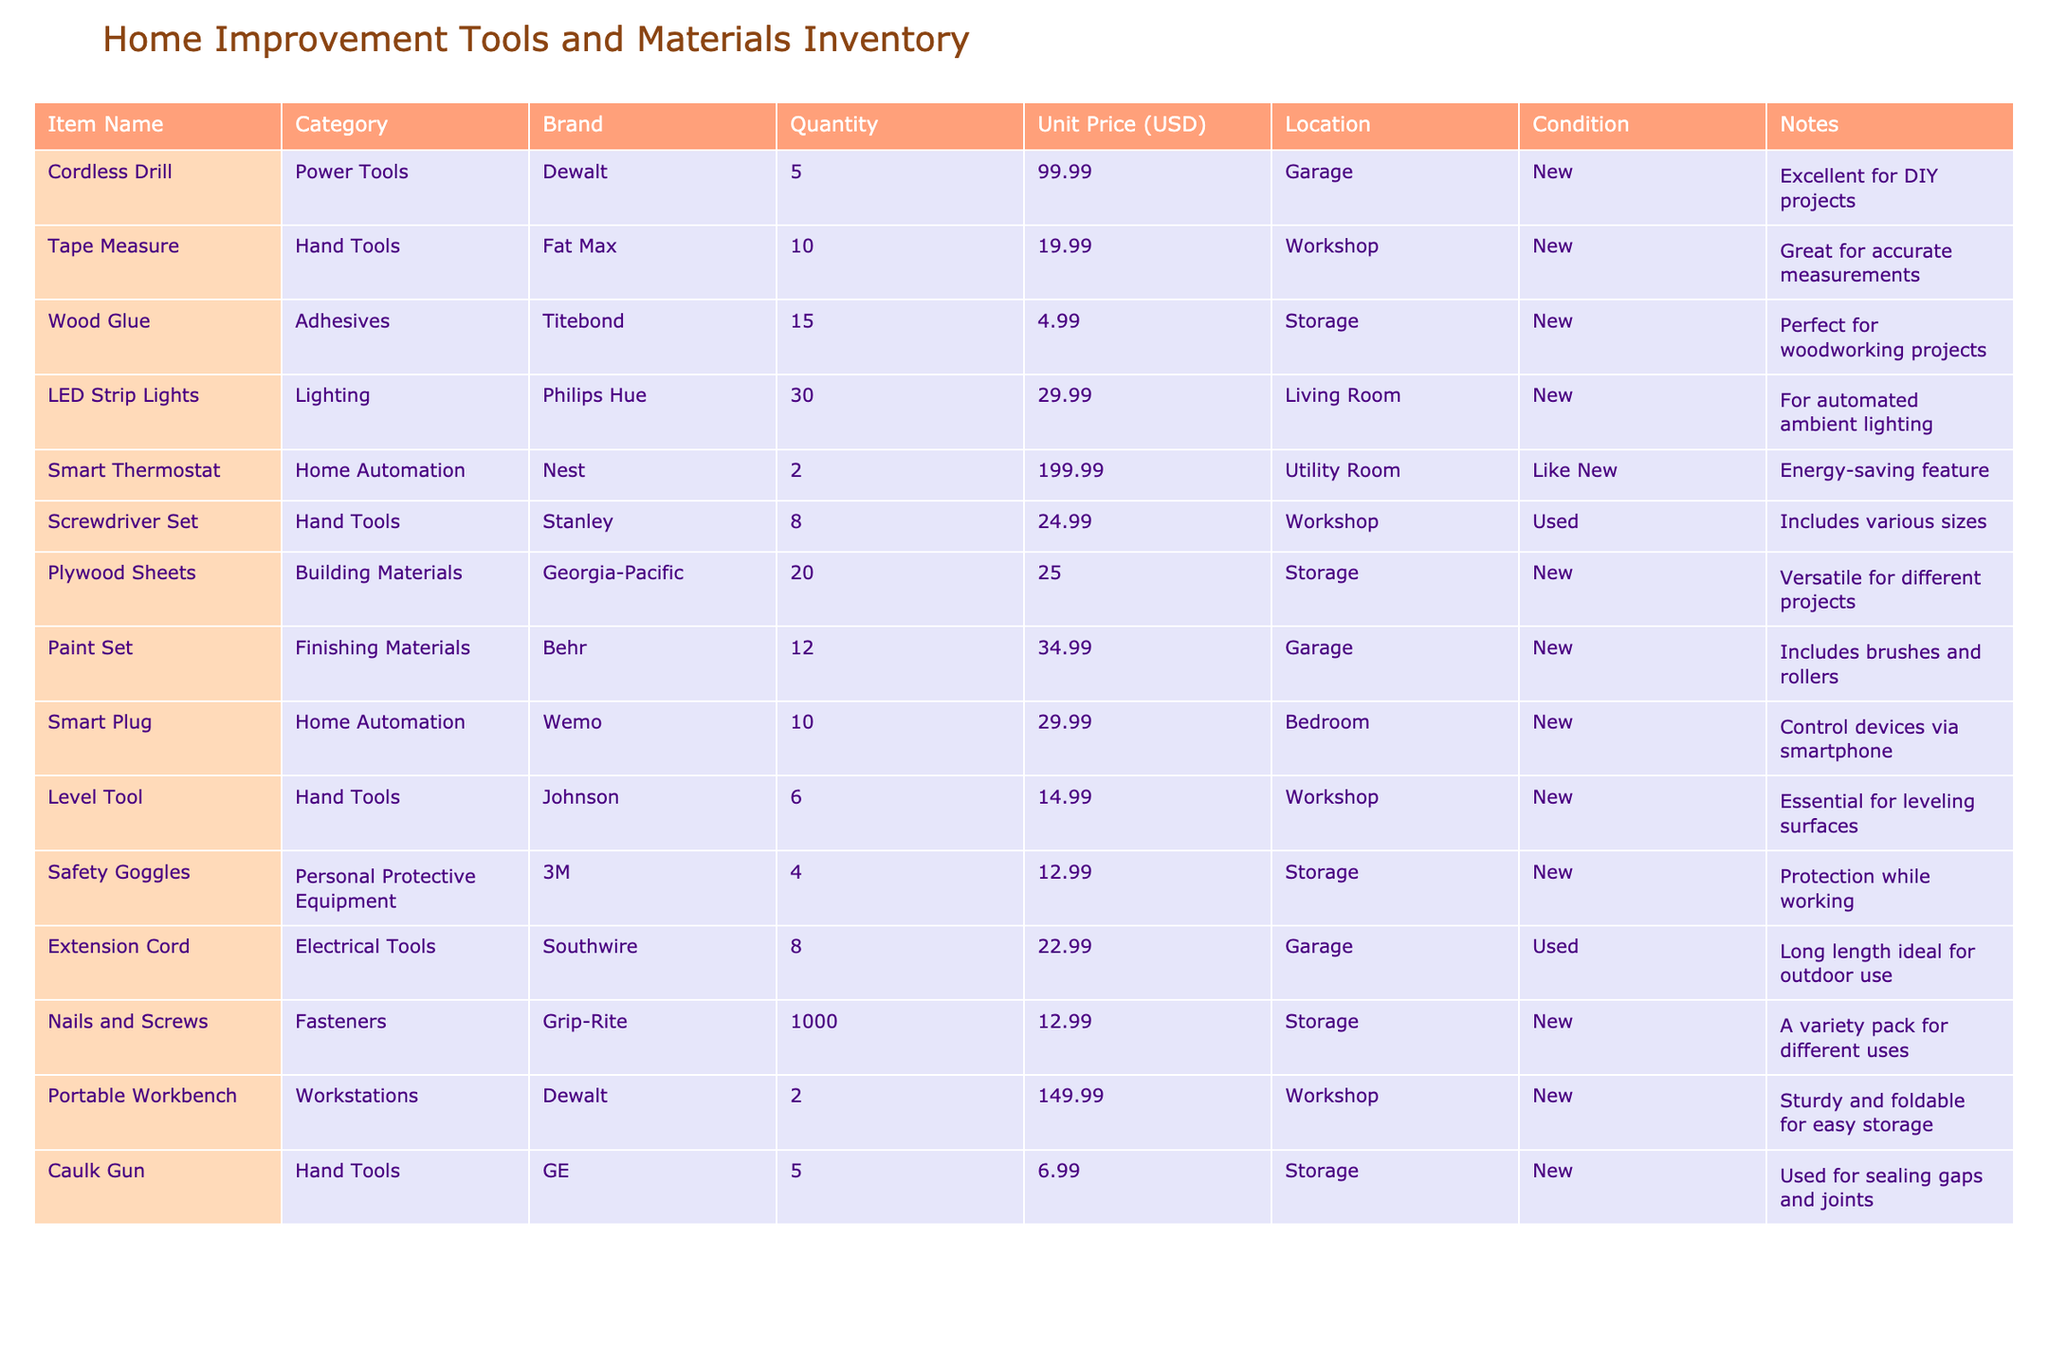What is the quantity of the Smart Thermostat? According to the table, the Smart Thermostat has a quantity listed as 2.
Answer: 2 What is the total quantity of Hand Tools in the inventory? The Hand Tools include Tape Measure (10), Screwdriver Set (8), and Level Tool (6). Adding these together gives 10 + 8 + 6 = 24.
Answer: 24 Are there any items in Used condition? Yes, the Screwdriver Set and Extension Cord are listed as Used.
Answer: Yes How much does the Portable Workbench cost? The table shows that the Portable Workbench has a Unit Price of 149.99 USD.
Answer: 149.99 USD Which items are located in the Workshop? The items located in the Workshop are the Tape Measure, Screwdriver Set, Level Tool, and Portable Workbench.
Answer: Tape Measure, Screwdriver Set, Level Tool, Portable Workbench What is the average price of the Adhesives and Fasteners categories? The Unit Price for Wood Glue in Adhesives is 4.99 USD and for Nails and Screws in Fasteners is 12.99 USD. Calculating the average gives (4.99 + 12.99)/2 = 8.99 USD.
Answer: 8.99 USD Is there a Smart Plug available in the inventory? Yes, there is a Smart Plug listed under Home Automation with a quantity of 10.
Answer: Yes What is the total value of Plywood Sheets in the inventory? The Unit Price for Plywood Sheets is 25.00 USD with a quantity of 20. The total value is calculated by multiplying these two values: 20 * 25.00 = 500.00 USD.
Answer: 500.00 USD How many items in the inventory are priced above 50 USD? The items are: Cordless Drill (99.99 USD), Smart Thermostat (199.99 USD), and Portable Workbench (149.99 USD). This totals to 3 items.
Answer: 3 